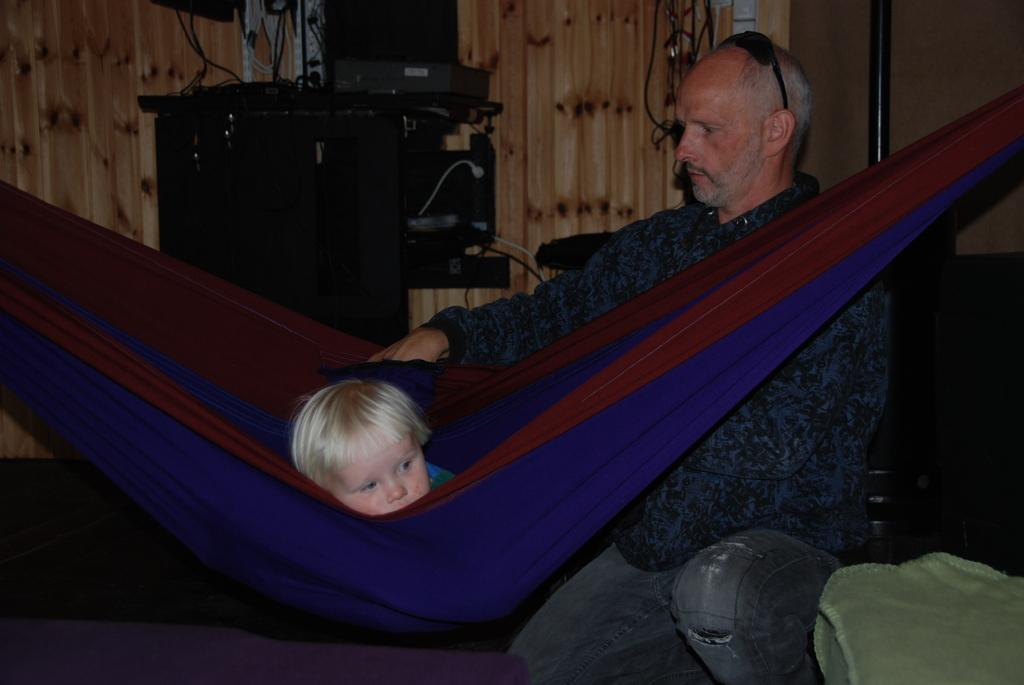Who is present in the image? There is a man and a child in the image. What is the man wearing? The man is wearing a uniform. What can be seen in the background of the image? There is a wooden wall and other objects visible in the background of the image. How many kittens are involved in the fight in the image? There is no fight or kittens present in the image. 